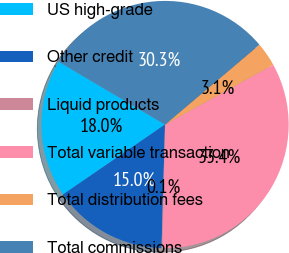Convert chart. <chart><loc_0><loc_0><loc_500><loc_500><pie_chart><fcel>US high-grade<fcel>Other credit<fcel>Liquid products<fcel>Total variable transaction<fcel>Total distribution fees<fcel>Total commissions<nl><fcel>18.05%<fcel>14.99%<fcel>0.09%<fcel>33.39%<fcel>3.15%<fcel>30.33%<nl></chart> 